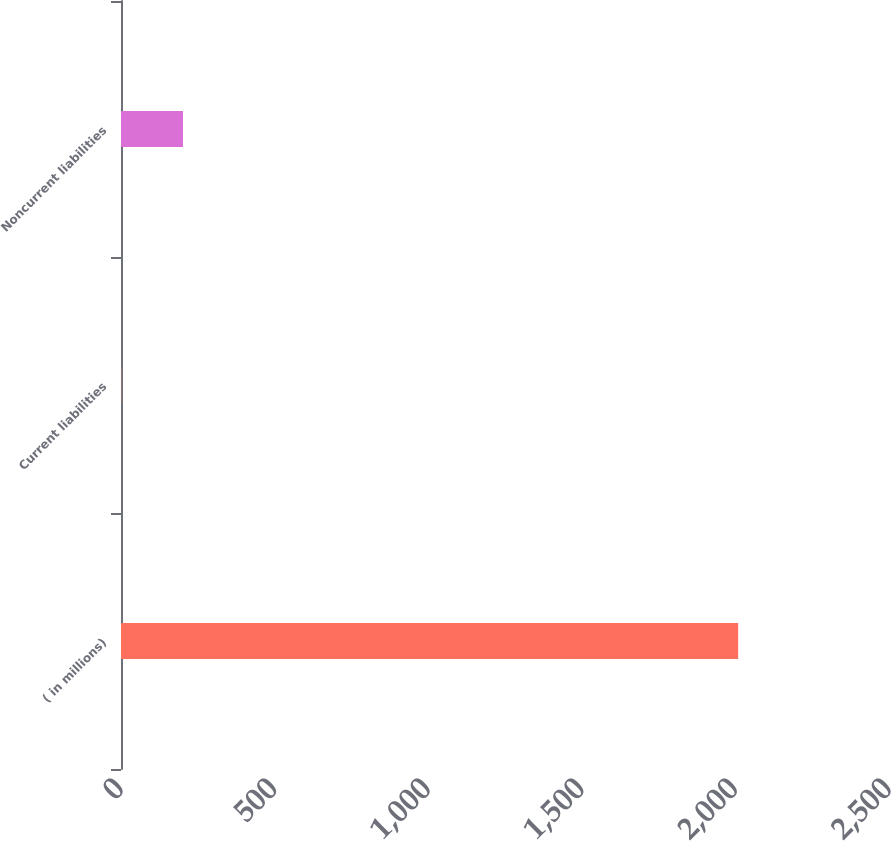Convert chart to OTSL. <chart><loc_0><loc_0><loc_500><loc_500><bar_chart><fcel>( in millions)<fcel>Current liabilities<fcel>Noncurrent liabilities<nl><fcel>2009<fcel>1<fcel>201.8<nl></chart> 